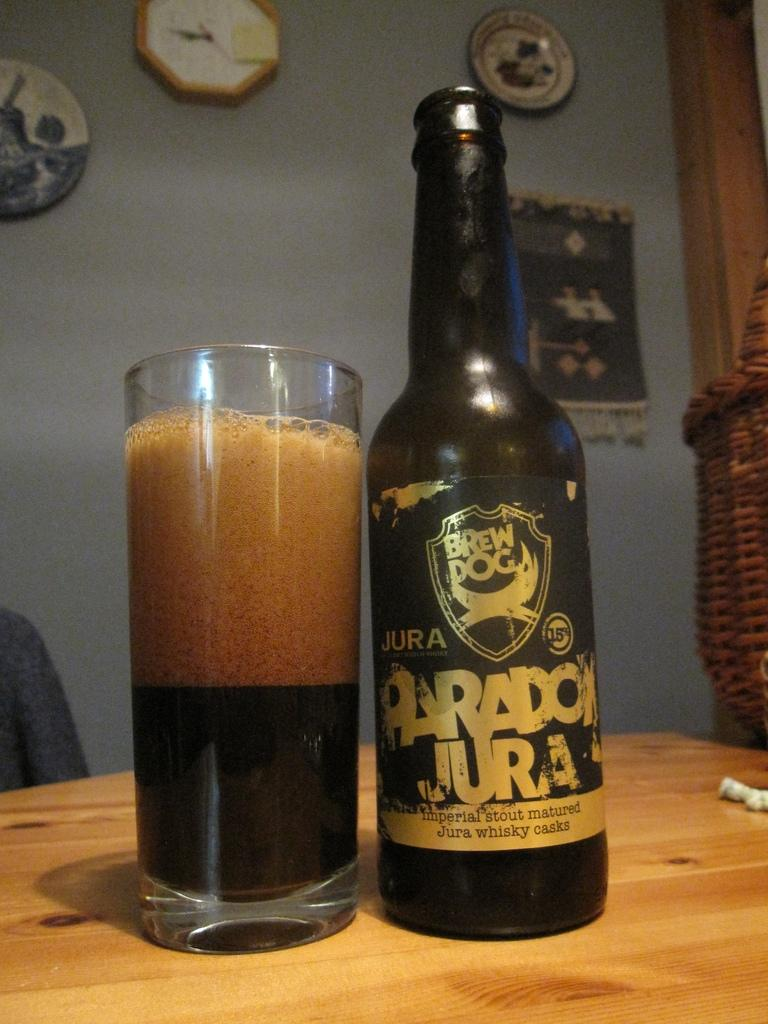<image>
Provide a brief description of the given image. A wooden table with a drinking glass and a bottle of Paradox Jura  whiskey. 